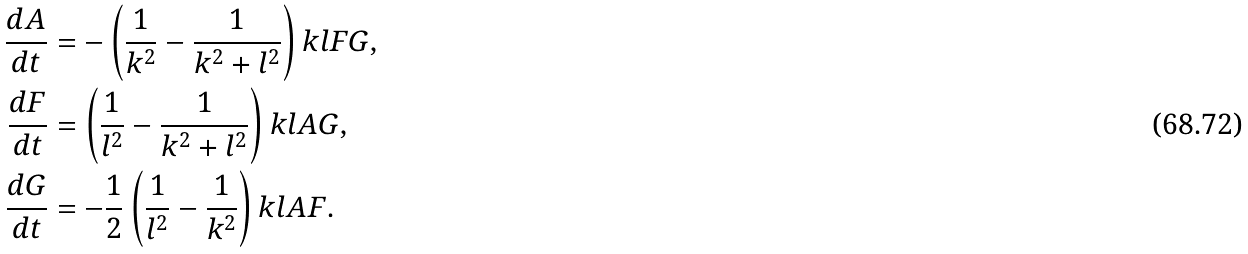Convert formula to latex. <formula><loc_0><loc_0><loc_500><loc_500>\frac { d A } { d t } & = - \left ( \frac { 1 } { k ^ { 2 } } - \frac { 1 } { k ^ { 2 } + l ^ { 2 } } \right ) k l F G , \\ \frac { d F } { d t } & = \left ( \frac { 1 } { l ^ { 2 } } - \frac { 1 } { k ^ { 2 } + l ^ { 2 } } \right ) k l A G , \\ \frac { d G } { d t } & = - \frac { 1 } { 2 } \left ( \frac { 1 } { l ^ { 2 } } - \frac { 1 } { k ^ { 2 } } \right ) k l A F .</formula> 